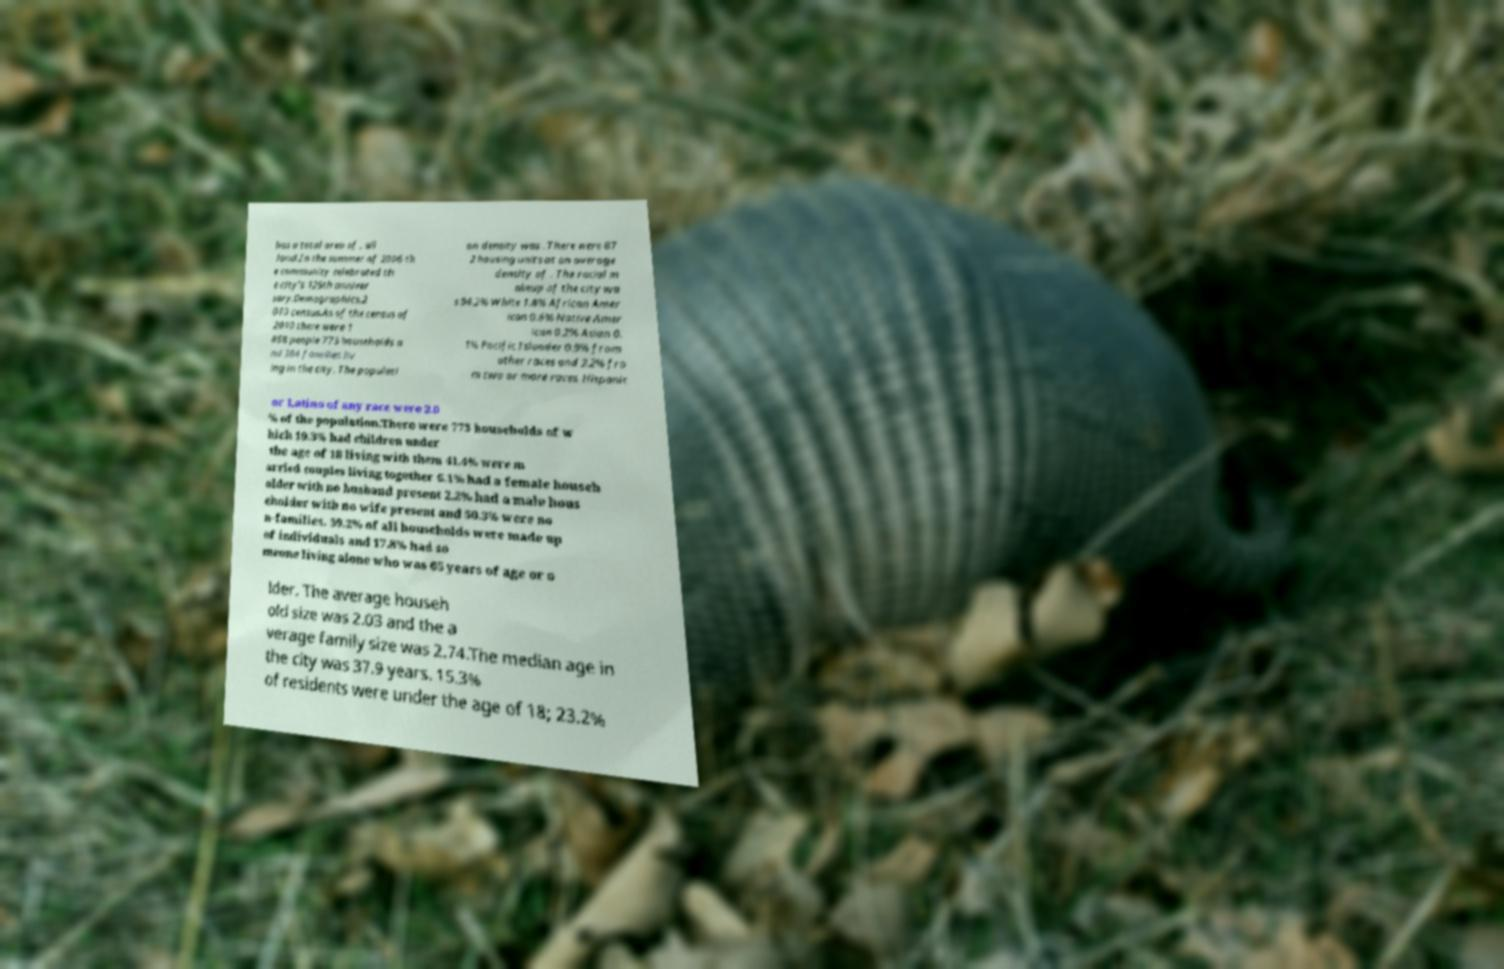There's text embedded in this image that I need extracted. Can you transcribe it verbatim? has a total area of , all land.In the summer of 2006 th e community celebrated th e city's 125th anniver sary.Demographics.2 010 census.As of the census of 2010 there were 1 858 people 773 households a nd 384 families liv ing in the city. The populati on density was . There were 87 2 housing units at an average density of . The racial m akeup of the city wa s 94.2% White 1.8% African Amer ican 0.6% Native Amer ican 0.2% Asian 0. 1% Pacific Islander 0.9% from other races and 2.2% fro m two or more races. Hispanic or Latino of any race were 2.0 % of the population.There were 773 households of w hich 19.3% had children under the age of 18 living with them 41.4% were m arried couples living together 6.1% had a female househ older with no husband present 2.2% had a male hous eholder with no wife present and 50.3% were no n-families. 39.2% of all households were made up of individuals and 17.8% had so meone living alone who was 65 years of age or o lder. The average househ old size was 2.03 and the a verage family size was 2.74.The median age in the city was 37.9 years. 15.3% of residents were under the age of 18; 23.2% 